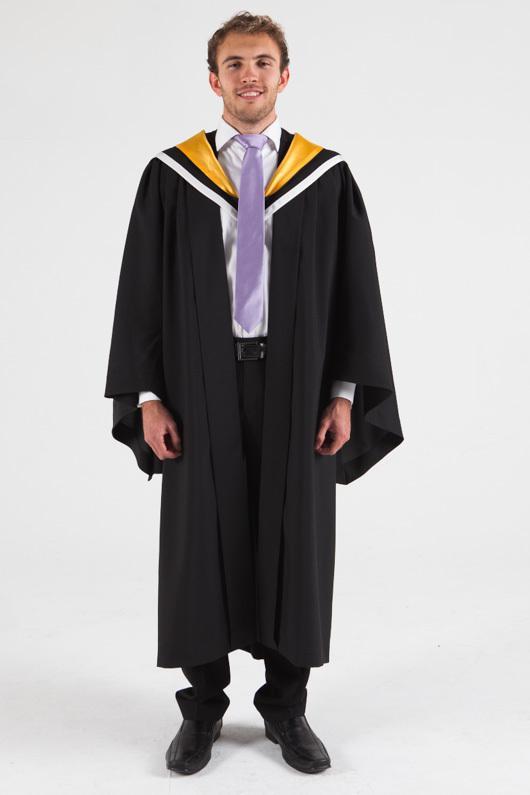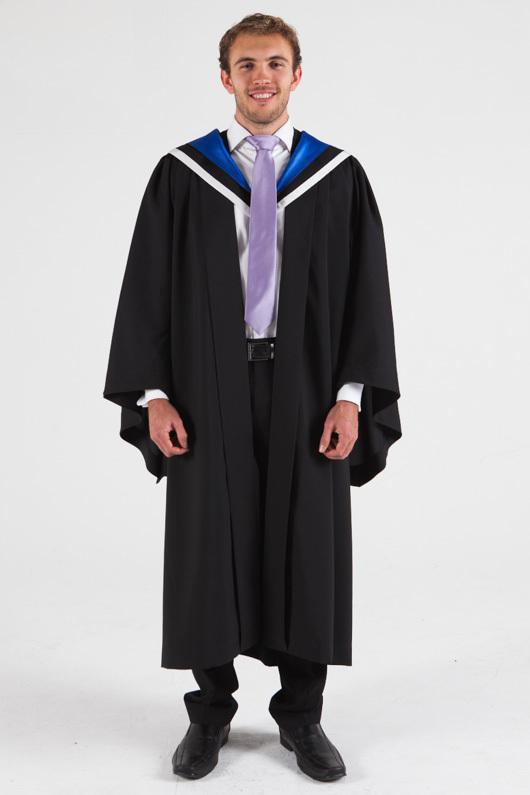The first image is the image on the left, the second image is the image on the right. For the images shown, is this caption "There are more unworn clothes than people." true? Answer yes or no. No. The first image is the image on the left, the second image is the image on the right. Evaluate the accuracy of this statement regarding the images: "An image includes a young man standing at a leftward-turned angle, modeling a graduation robe and cap.". Is it true? Answer yes or no. No. 